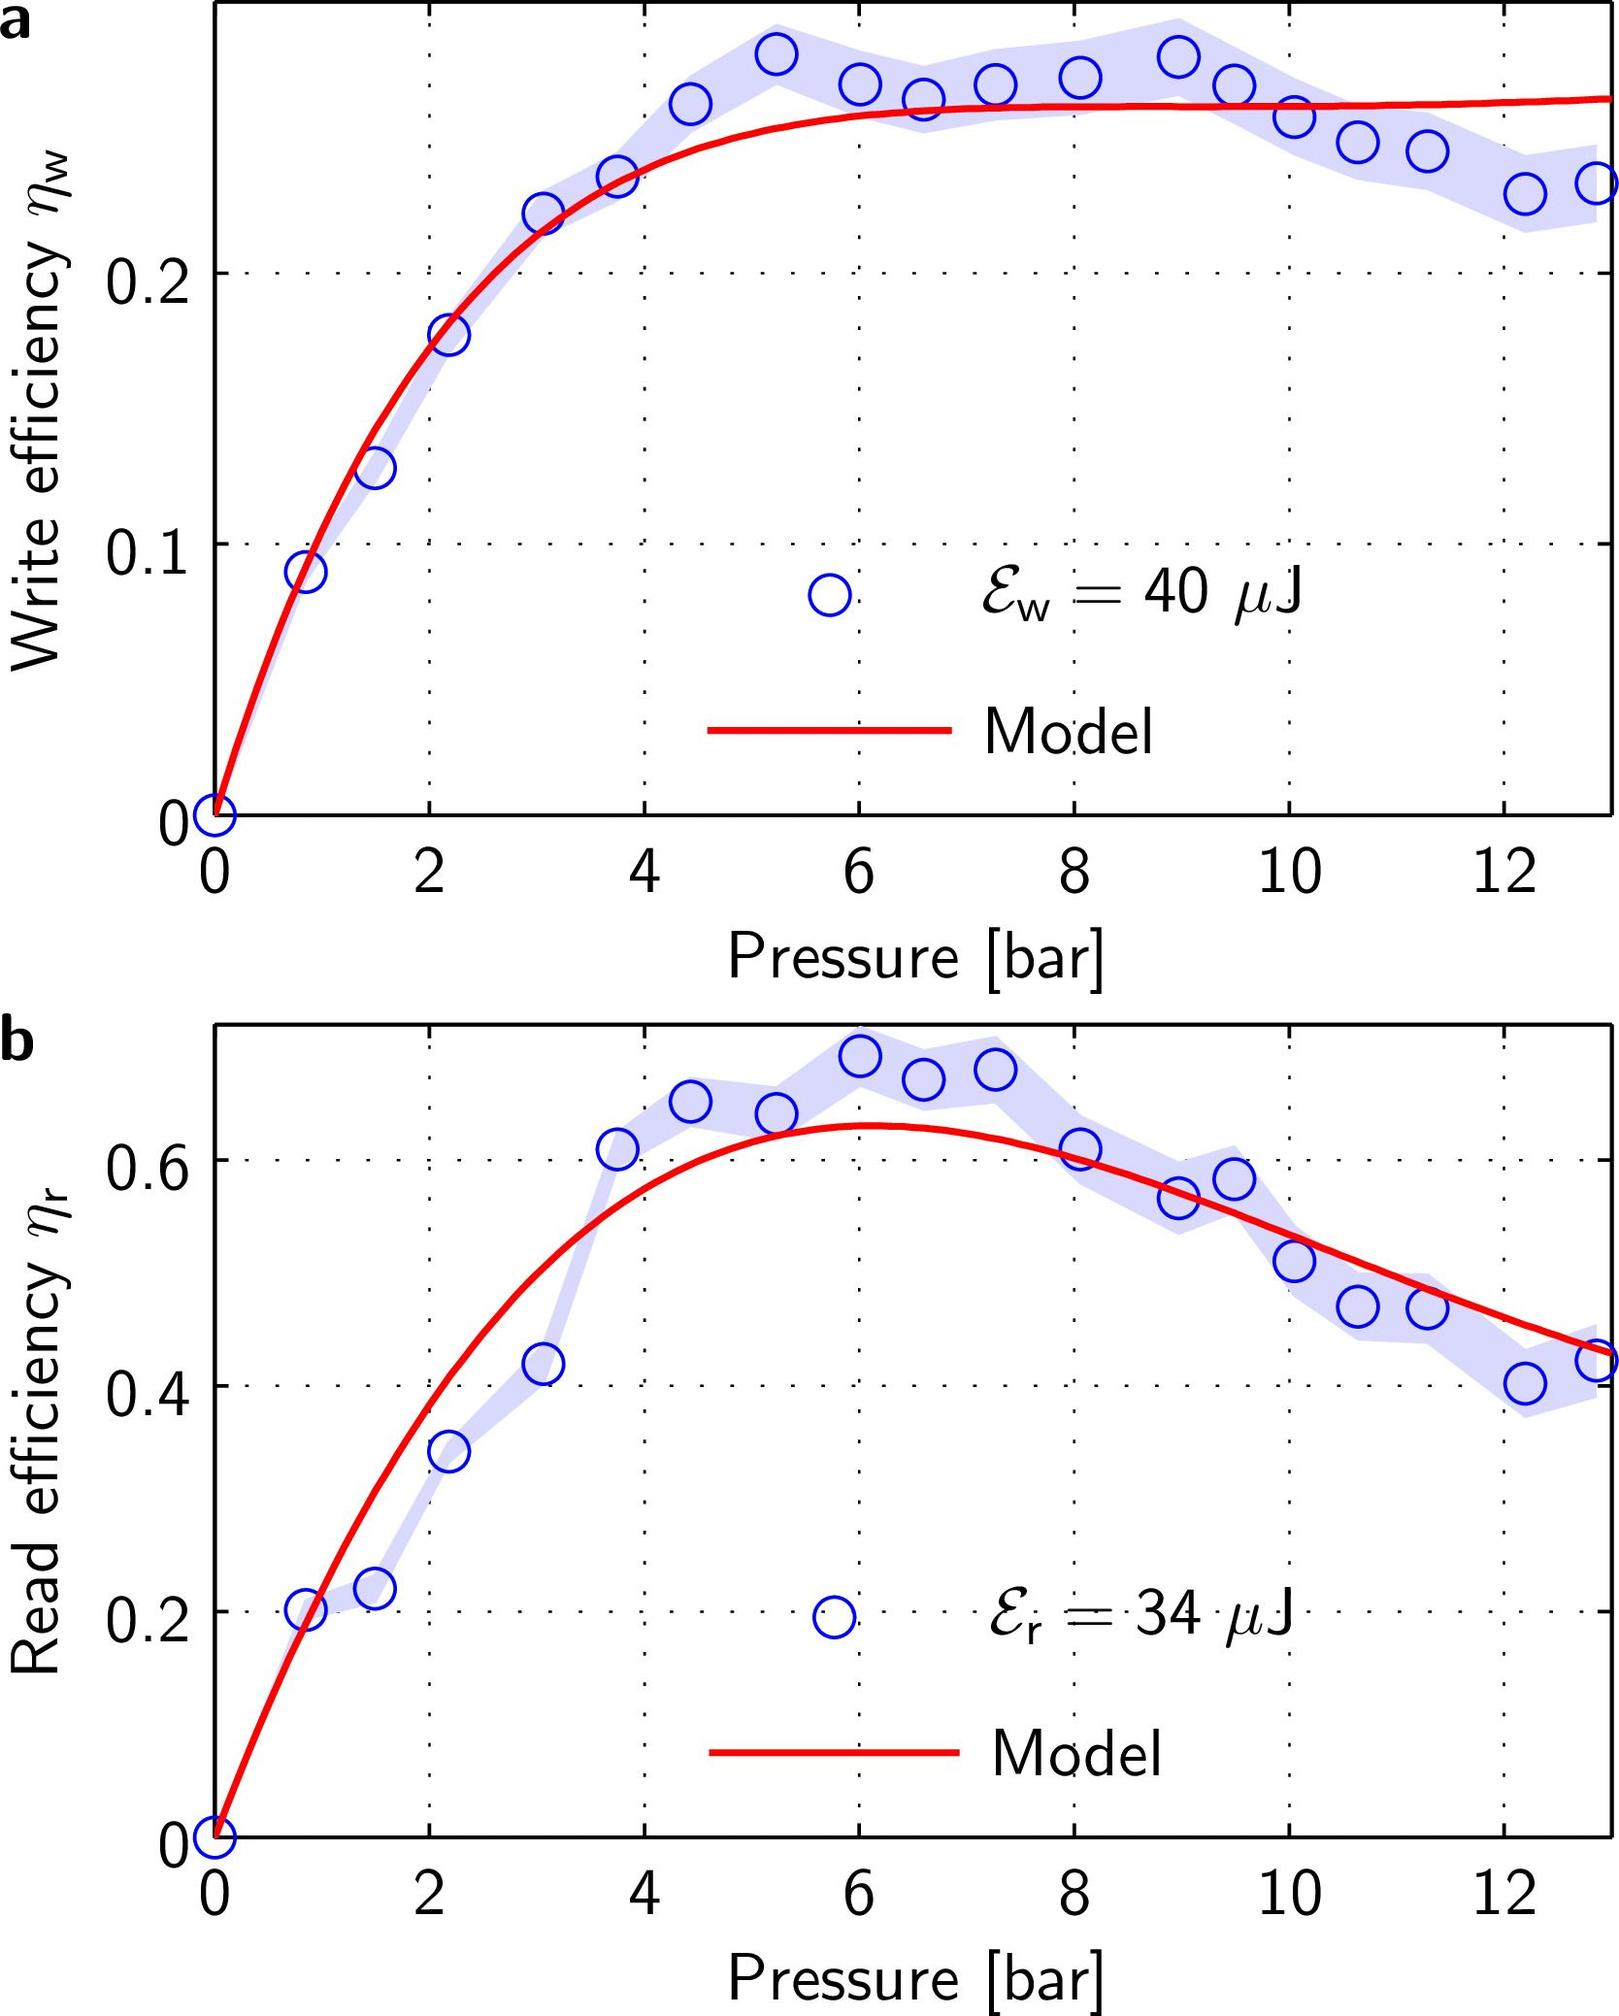If the energy utilized for writing (\(E_W\)) is increased from 40 μJ, what could be the expected effect on the write efficiency (\(\eta_W\)) according to the model? A. The peak efficiency would shift to a lower pressure value. B. The write efficiency would decrease at all pressures. C. The peak efficiency would shift to a higher pressure value. D. The write efficiency would remain unchanged. The graph in figure a indicates that the write efficiency (\(\eta_W\)) peaks at a certain pressure range (6 to 8 bar) for a given energy value (40 μJ). If the energy is increased, it's likely that the system would reach peak efficiency at a lower energy level, thus potentially shifting the peak to a lower pressure value. Therefore, the correct answer is A. 